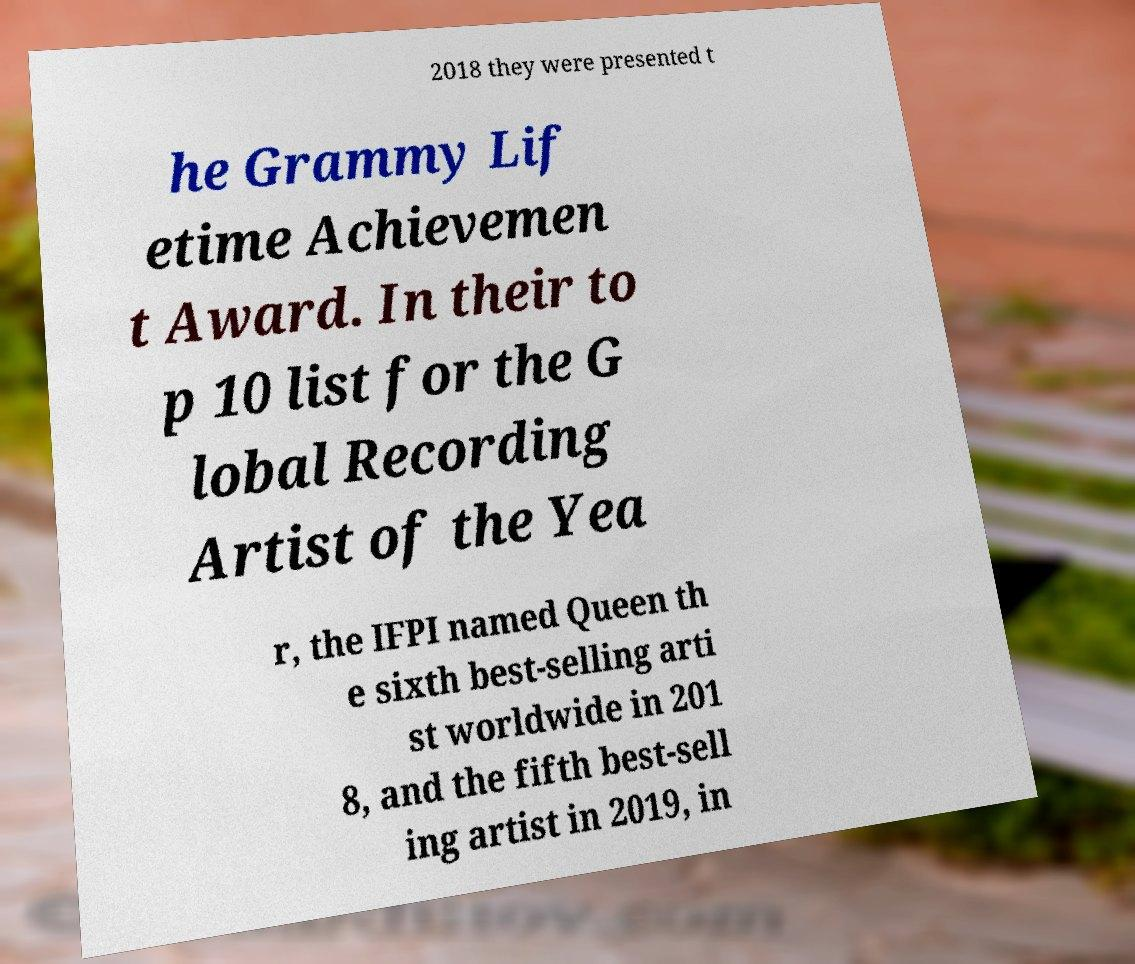There's text embedded in this image that I need extracted. Can you transcribe it verbatim? 2018 they were presented t he Grammy Lif etime Achievemen t Award. In their to p 10 list for the G lobal Recording Artist of the Yea r, the IFPI named Queen th e sixth best-selling arti st worldwide in 201 8, and the fifth best-sell ing artist in 2019, in 